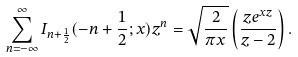Convert formula to latex. <formula><loc_0><loc_0><loc_500><loc_500>\sum _ { n = - \infty } ^ { \infty } I _ { n + \frac { 1 } { 2 } } ( - n + \frac { 1 } { 2 } ; x ) z ^ { n } = \sqrt { \frac { 2 } { \pi x } } \left ( \frac { z e ^ { x z } } { z - 2 } \right ) .</formula> 